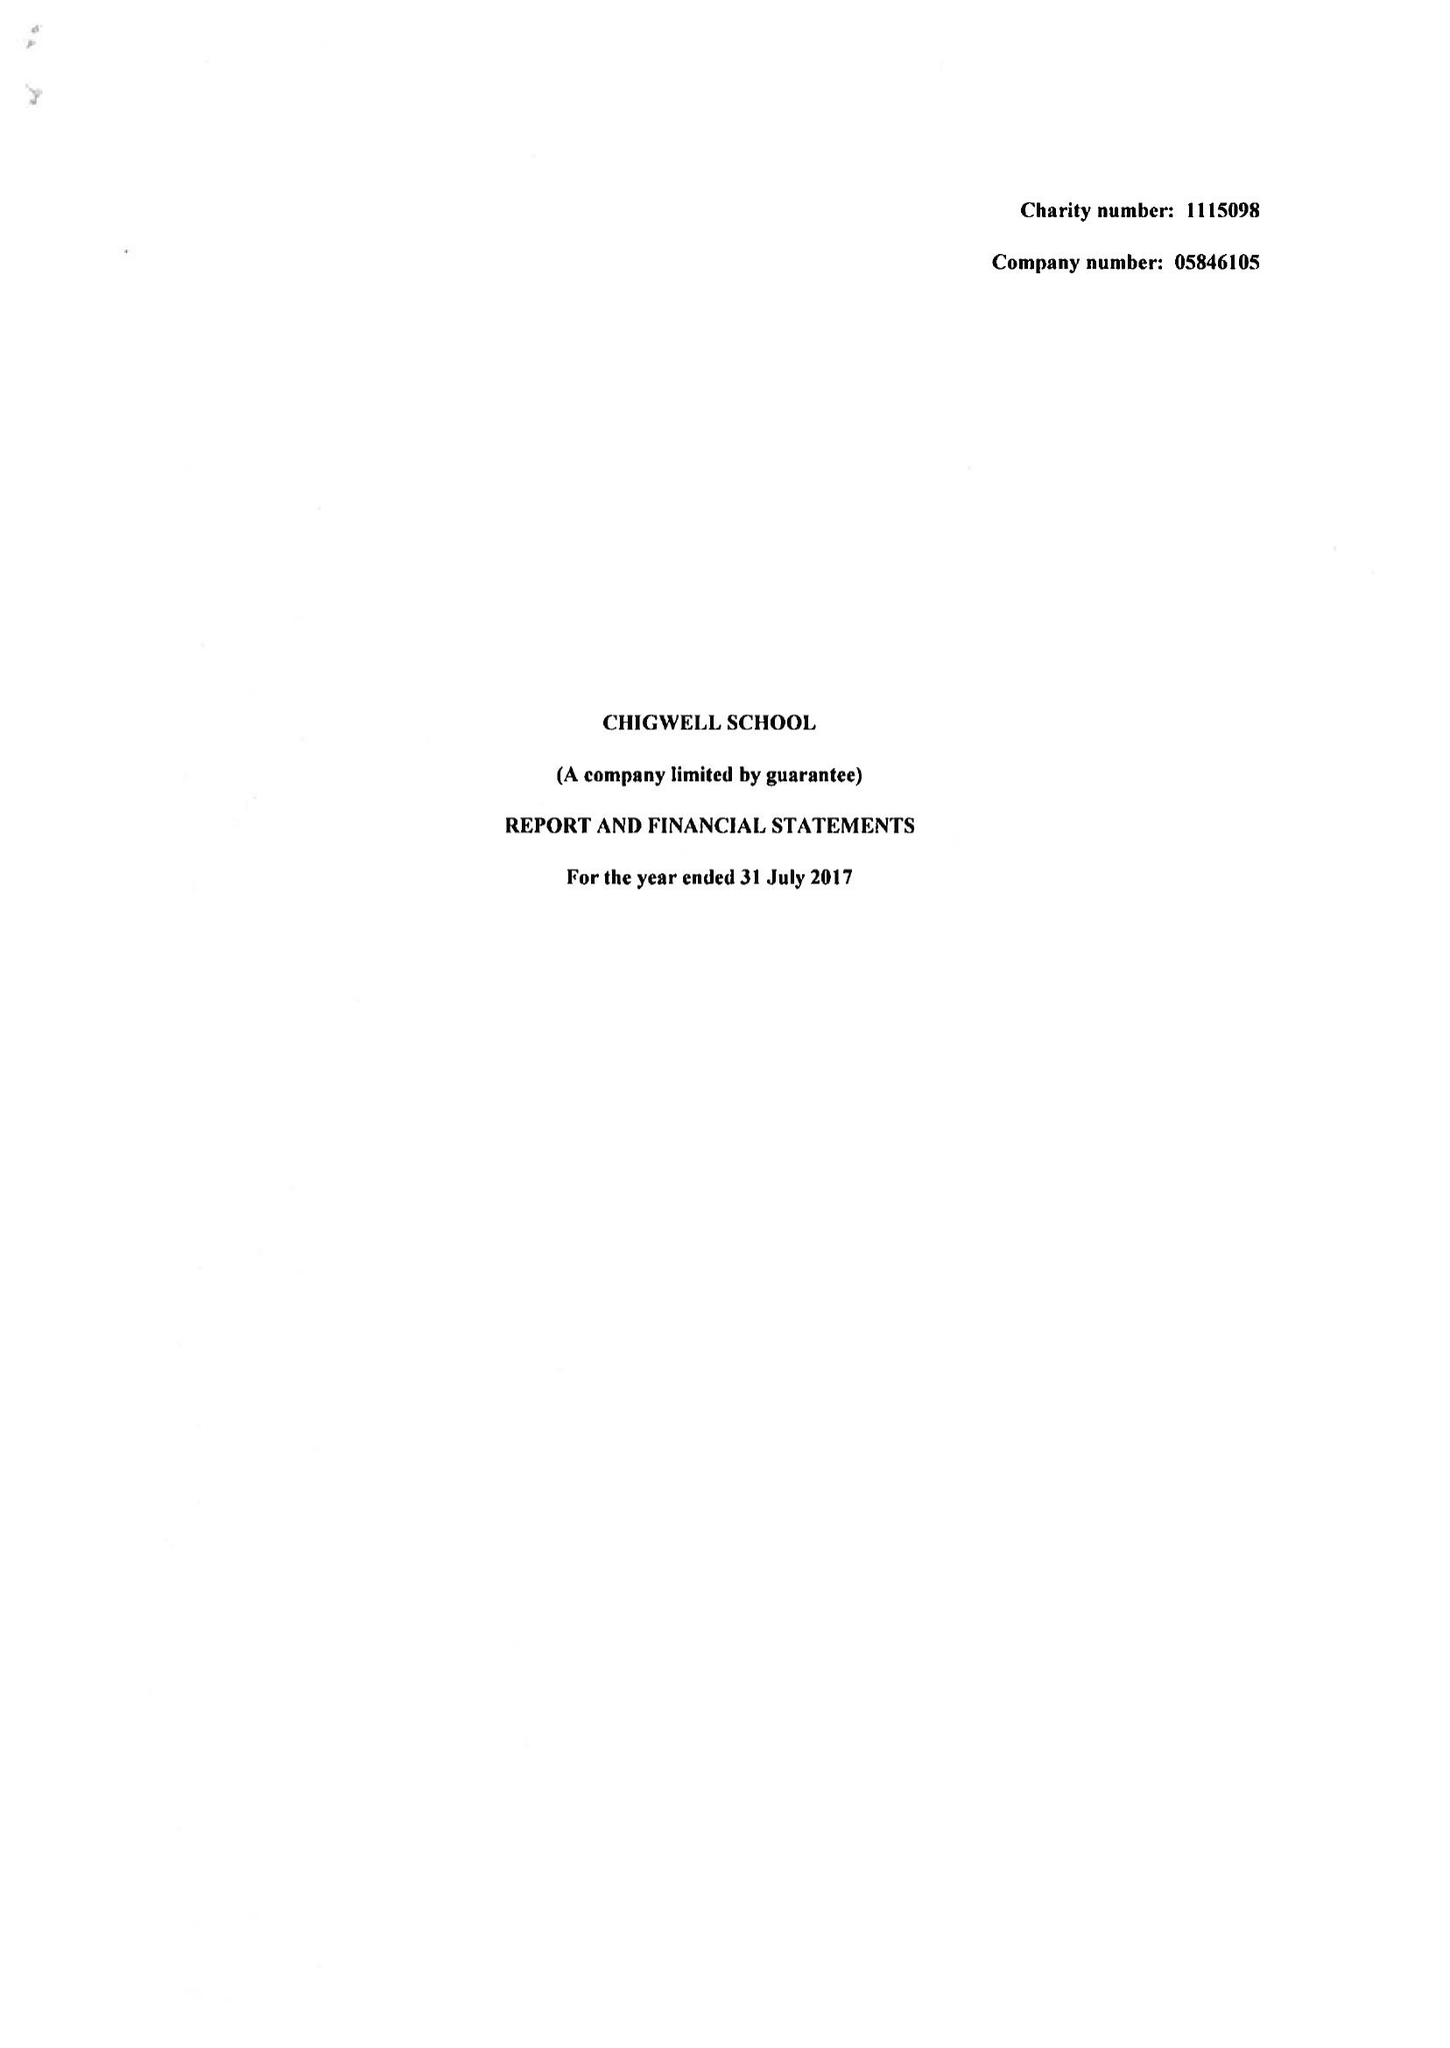What is the value for the address__post_town?
Answer the question using a single word or phrase. CHIGWELL 